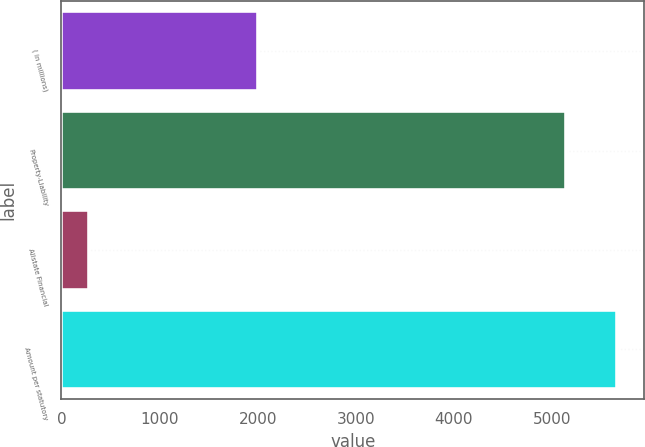Convert chart to OTSL. <chart><loc_0><loc_0><loc_500><loc_500><bar_chart><fcel>( in millions)<fcel>Property-Liability<fcel>Allstate Financial<fcel>Amount per statutory<nl><fcel>2006<fcel>5142<fcel>277<fcel>5656.2<nl></chart> 